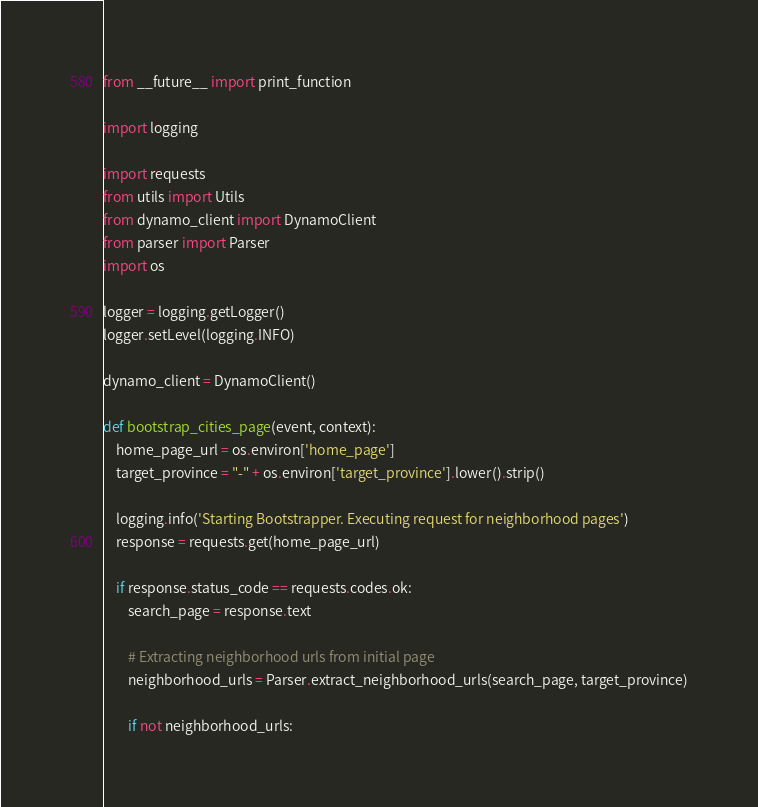<code> <loc_0><loc_0><loc_500><loc_500><_Python_>from __future__ import print_function

import logging

import requests
from utils import Utils
from dynamo_client import DynamoClient
from parser import Parser
import os

logger = logging.getLogger()
logger.setLevel(logging.INFO)

dynamo_client = DynamoClient()

def bootstrap_cities_page(event, context):
    home_page_url = os.environ['home_page']
    target_province = "-" + os.environ['target_province'].lower().strip()

    logging.info('Starting Bootstrapper. Executing request for neighborhood pages')
    response = requests.get(home_page_url)

    if response.status_code == requests.codes.ok:
        search_page = response.text
        
        # Extracting neighborhood urls from initial page
        neighborhood_urls = Parser.extract_neighborhood_urls(search_page, target_province)

        if not neighborhood_urls:</code> 